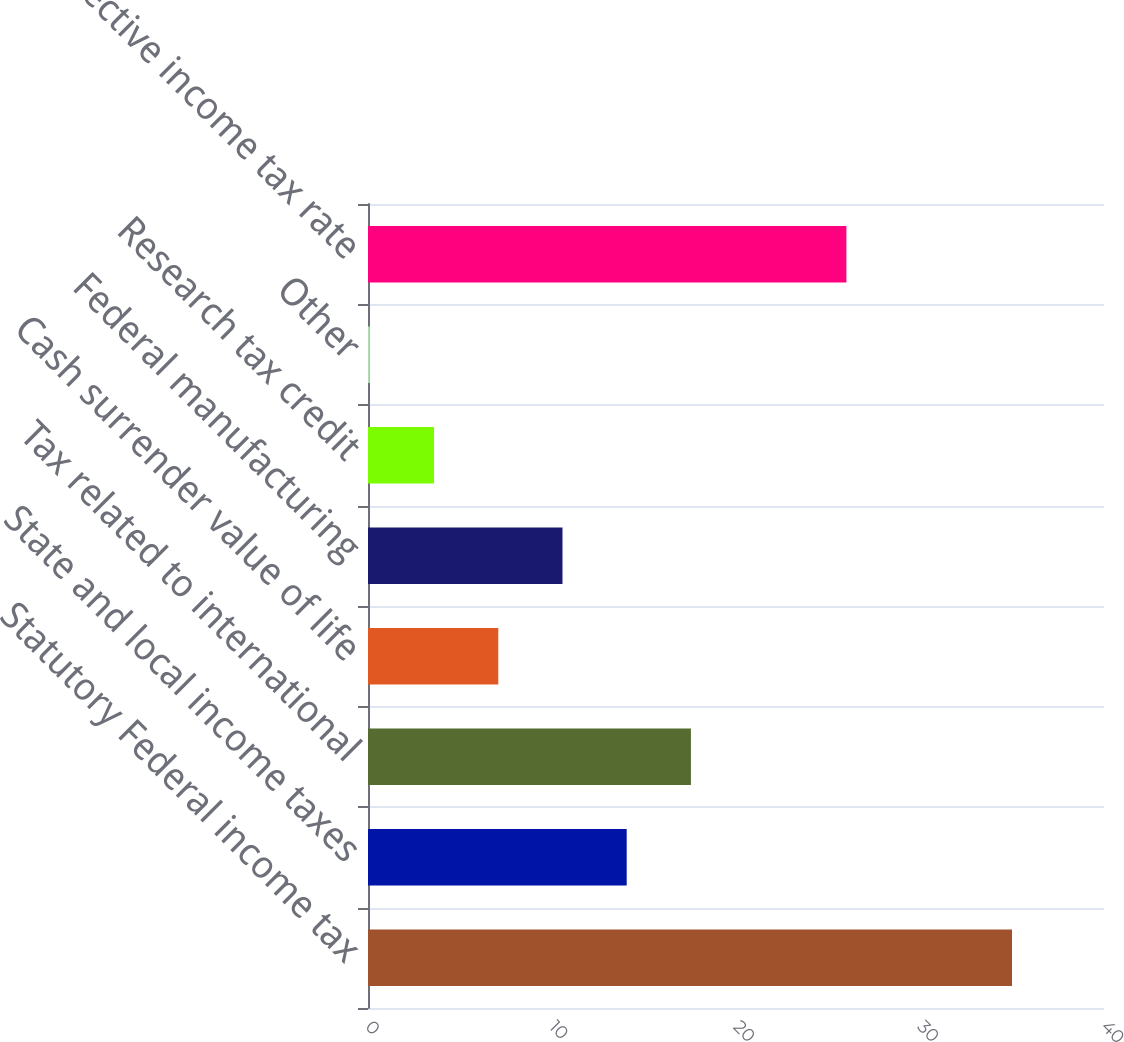Convert chart to OTSL. <chart><loc_0><loc_0><loc_500><loc_500><bar_chart><fcel>Statutory Federal income tax<fcel>State and local income taxes<fcel>Tax related to international<fcel>Cash surrender value of life<fcel>Federal manufacturing<fcel>Research tax credit<fcel>Other<fcel>Effective income tax rate<nl><fcel>35<fcel>14.06<fcel>17.55<fcel>7.08<fcel>10.57<fcel>3.59<fcel>0.1<fcel>26<nl></chart> 